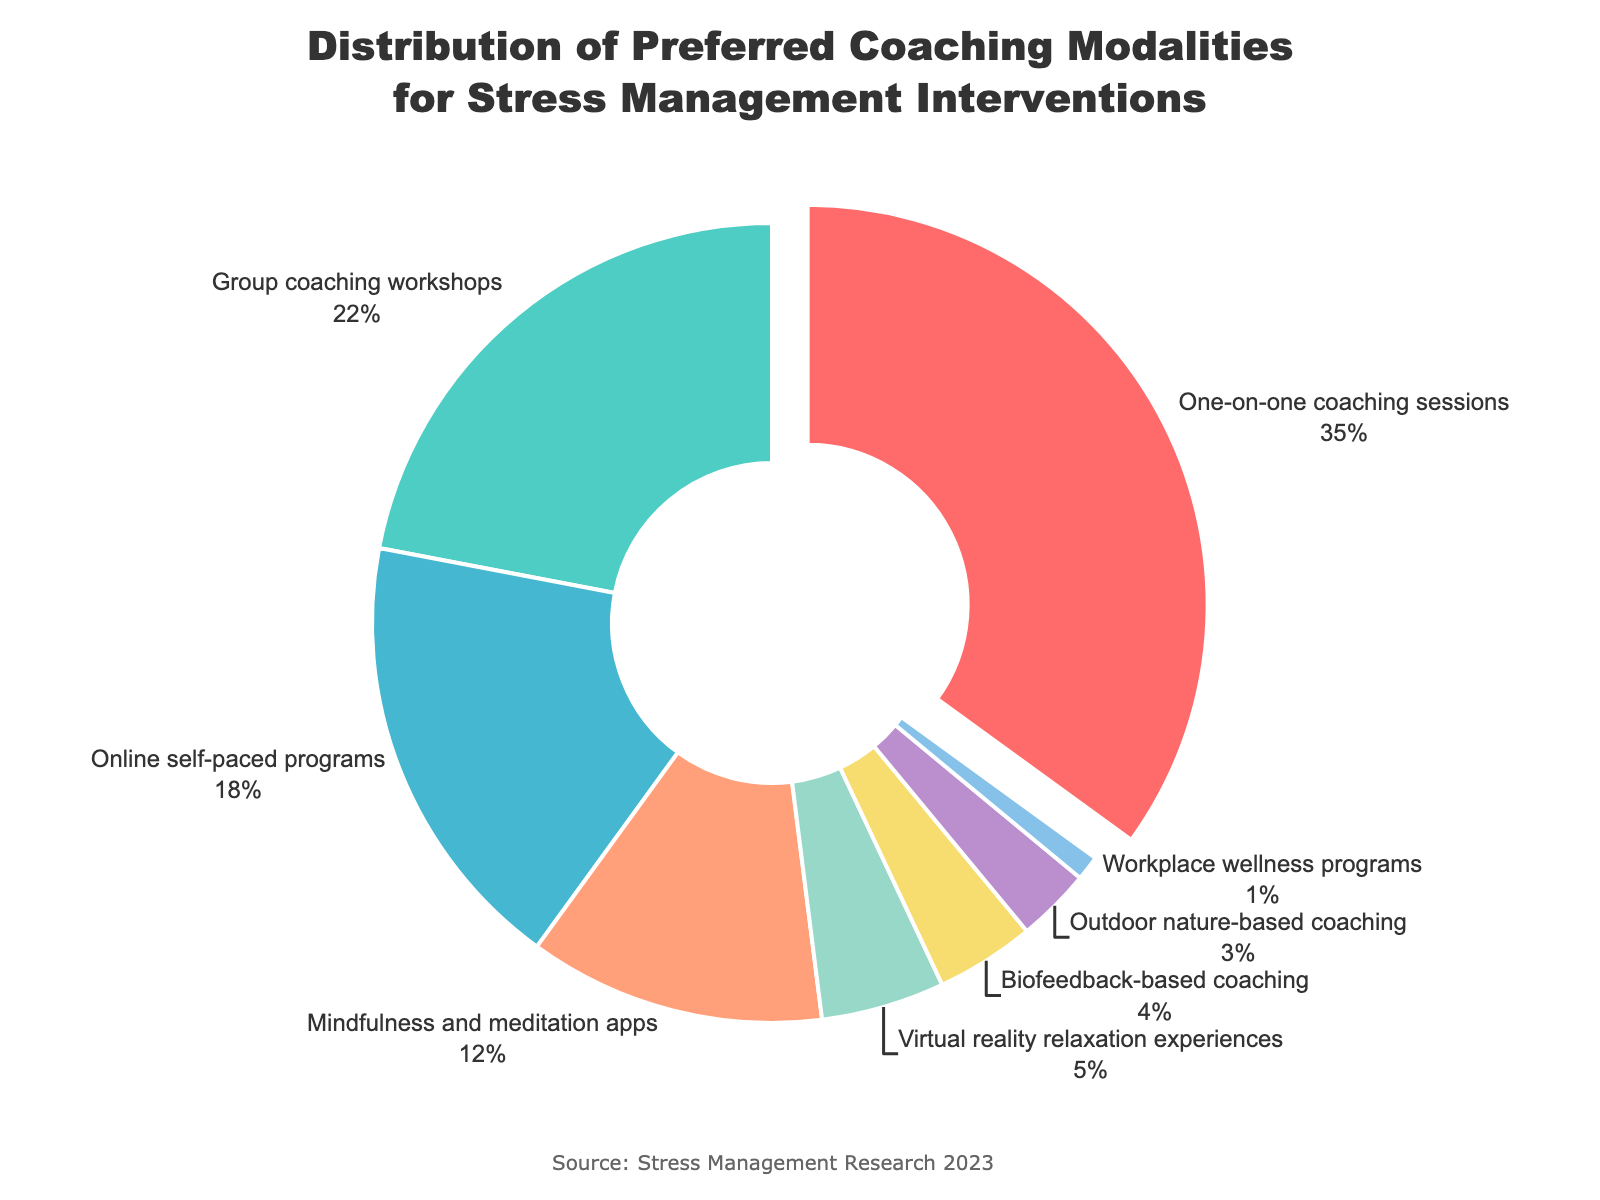What modality has the highest percentage according to the pie chart? By examining the pie chart, we can see that the "One-on-one coaching sessions" segment is the largest, which means it has the highest percentage.
Answer: One-on-one coaching sessions What is the combined percentage of "Virtual reality relaxation experiences" and "Outdoor nature-based coaching"? Sum the percentages for "Virtual reality relaxation experiences" (5%) and "Outdoor nature-based coaching" (3%), the combined percentage is 5 + 3 = 8%.
Answer: 8% How does the percentage of "Group coaching workshops" compare to "Online self-paced programs"? To compare the percentages, look at the segments: "Group coaching workshops" is 22%, and "Online self-paced programs" is 18%. Therefore, "Group coaching workshops" has a higher percentage than "Online self-paced programs."
Answer: Higher What is the total percentage of modalities with a percentage below 10%? Sum the percentages of all modalities below 10%: "Virtual reality relaxation experiences" (5%), "Biofeedback-based coaching" (4%), "Outdoor nature-based coaching" (3%), and "Workplace wellness programs" (1%). The total is 5 + 4 + 3 + 1 = 13%.
Answer: 13% Which modality is represented by the red segment of the pie chart? By looking at the color of each segment and the corresponding labels, the red segment represents "One-on-one coaching sessions."
Answer: One-on-one coaching sessions What is the difference in percentage between "Mindfulness and meditation apps" and "Biofeedback-based coaching"? Subtract the percentage of "Biofeedback-based coaching" (4%) from "Mindfulness and meditation apps" (12%). The difference is 12 - 4 = 8%.
Answer: 8% Which modalities have a percentage greater than 20%? Identify segments with percentages over 20%: "One-on-one coaching sessions" (35%) and "Group coaching workshops" (22%).
Answer: One-on-one coaching sessions, Group coaching workshops What percentage is left if we exclude the "One-on-one coaching sessions"? Subtract the percentage of "One-on-one coaching sessions" from the total 100%: 100 - 35 = 65%.
Answer: 65% What modalities are represented by segments outside the median value percentage? The median value of the percentages can be determined by ordering the values: 1, 3, 4, 5, 12, 18, 22, 35. The median is between 5 and 12, so outside these values are modalities "One-on-one coaching sessions", "Group coaching workshops", and "Online self-paced programs" representing above median values, and modalities "Biofeedback-based coaching", "Outdoor nature-based coaching", and "Workplace wellness programs" representing below median values.
Answer: One-on-one coaching sessions, Group coaching workshops, Online self-paced programs, Biofeedback-based coaching, Outdoor nature-based coaching, Workplace wellness programs 